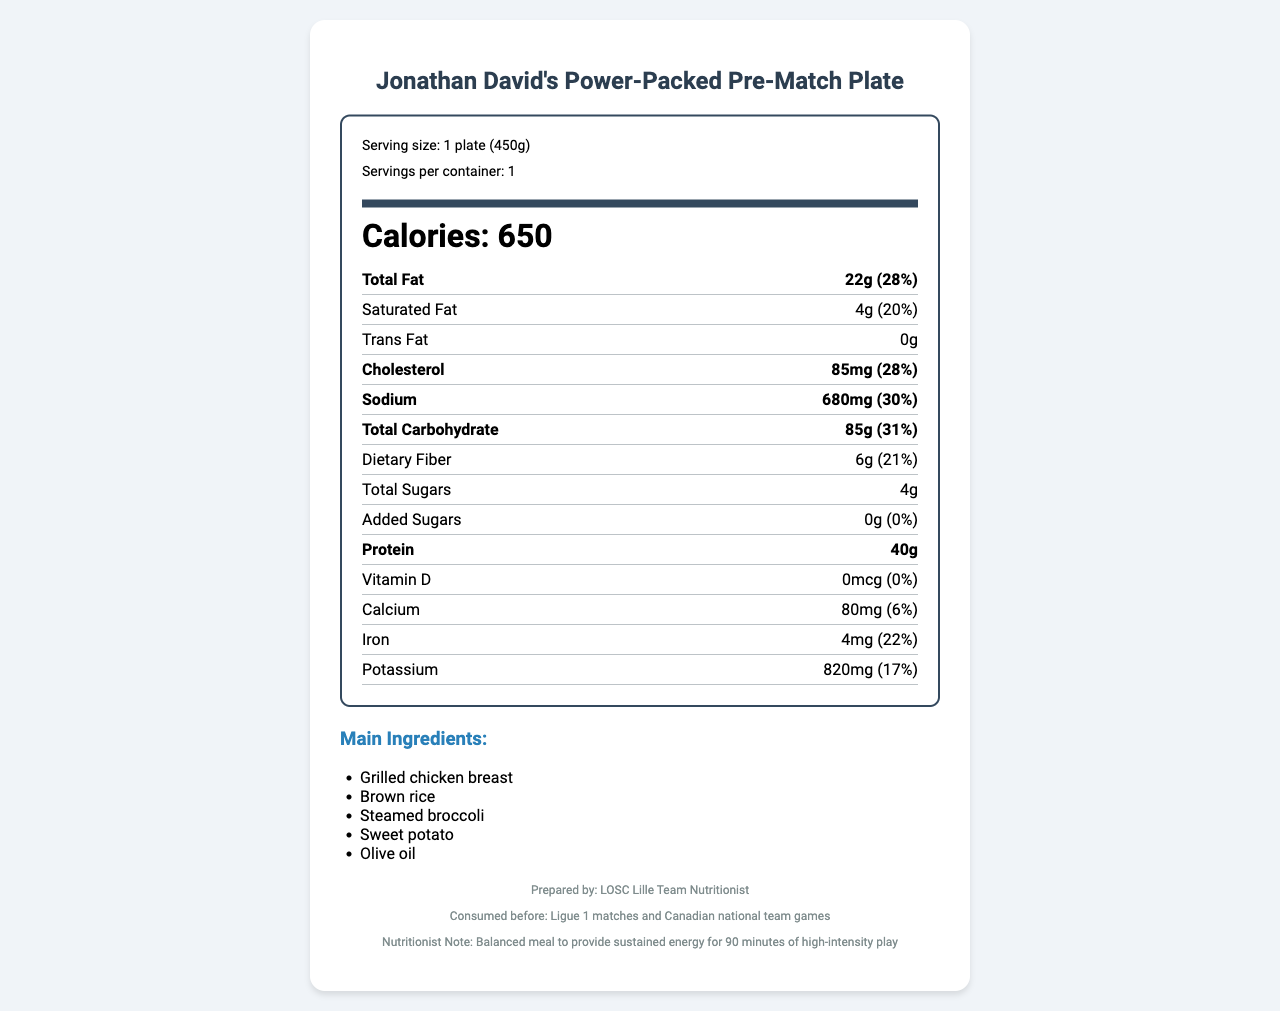what is the serving size? The document specifies the serving size as "1 plate (450g)" near the top.
Answer: 1 plate (450g) how many calories are there per serving? The document indicates that there are 650 calories per serving.
Answer: 650 what is the percentage daily value of total fat? The total fat content is listed as 22g, which represents 28% of the daily value.
Answer: 28% how much protein does this meal contain? The nutrition facts list 40g of protein for the meal.
Answer: 40g what are the main ingredients of the meal? The main ingredients are listed under the "Main Ingredients" section of the document.
Answer: Grilled chicken breast, Brown rice, Steamed broccoli, Sweet potato, Olive oil how is this meal labeled in terms of nutrition? A. Low-fat B. High-protein C. High-sugar The meal contains 40g of protein, which categorizes it as high-protein.
Answer: B what is the sodium content? A. 500mg B. 680mg C. 820mg D. 1000mg The sodium content is listed as 680mg, which is 30% of the daily value.
Answer: B what is the serving size? The serving size mentioned is "1 plate (450g)", which means it is a single plate with a weight of 450 grams.
Answer: 1 plate (450g) is the meal free of allergens? The document lists “None” under allergens, indicating there are no allergens present.
Answer: Yes summarize the nutrition facts label for this meal The summary encapsulates the main details, ingredients, nutritional content, and purpose of the meal.
Answer: Jonathan David's Power-Packed Pre-Match Plate is a balanced meal prepared by LOSC Lille Team Nutritionist, composed mainly of grilled chicken breast, brown rice, steamed broccoli, sweet potato, and olive oil. It offers 650 calories per serving, with key nutrients like 40g of protein, 85g of carbohydrates, 22g of fat, and significant percentages of daily values for sodium, iron, and potassium. The meal is allergen-free and designed to provide sustained energy for 90 minutes of high-intensity play. what is the cholesterol content of the meal? The cholesterol content is listed as 85mg, which is 28% of the daily value.
Answer: 85mg how many grams of dietary fiber are in the meal? The document states that the meal contains 6g of dietary fiber, which is 21% of the daily value.
Answer: 6g can the calcium content percentage be determined from the document? The document specifies that the calcium content is 80mg, which is 6% of the daily value.
Answer: Yes does the meal contain trans fat? The document lists 0g of trans fat.
Answer: No what is Jonathan David's favorite pre-match meal called? The title of the meal is "Jonathan David's Power-Packed Pre-Match Plate."
Answer: Jonathan David's Power-Packed Pre-Match Plate how much potassium is in the meal? A. 17% B. 22% C. 30% D. 28% The potassium content in the meal is 820mg, which is 17% of the daily value.
Answer: A which vitamin is not present in the meal? The document lists 0mcg of Vitamin D, indicating its absence.
Answer: Vitamin D provide details about who prepared the meal and for what purpose This information is found in the footer of the document.
Answer: The meal is prepared by the LOSC Lille Team Nutritionist and is consumed before Ligue 1 matches and Canadian national team games to provide sustained energy for 90 minutes of high-intensity play. how much added sugar is in the meal? The document indicates that there is no added sugar in the meal.
Answer: 0g is this meal suitable for someone with a gluten intolerance? The document does not provide specific information about gluten or gluten-containing ingredients.
Answer: Not enough information 